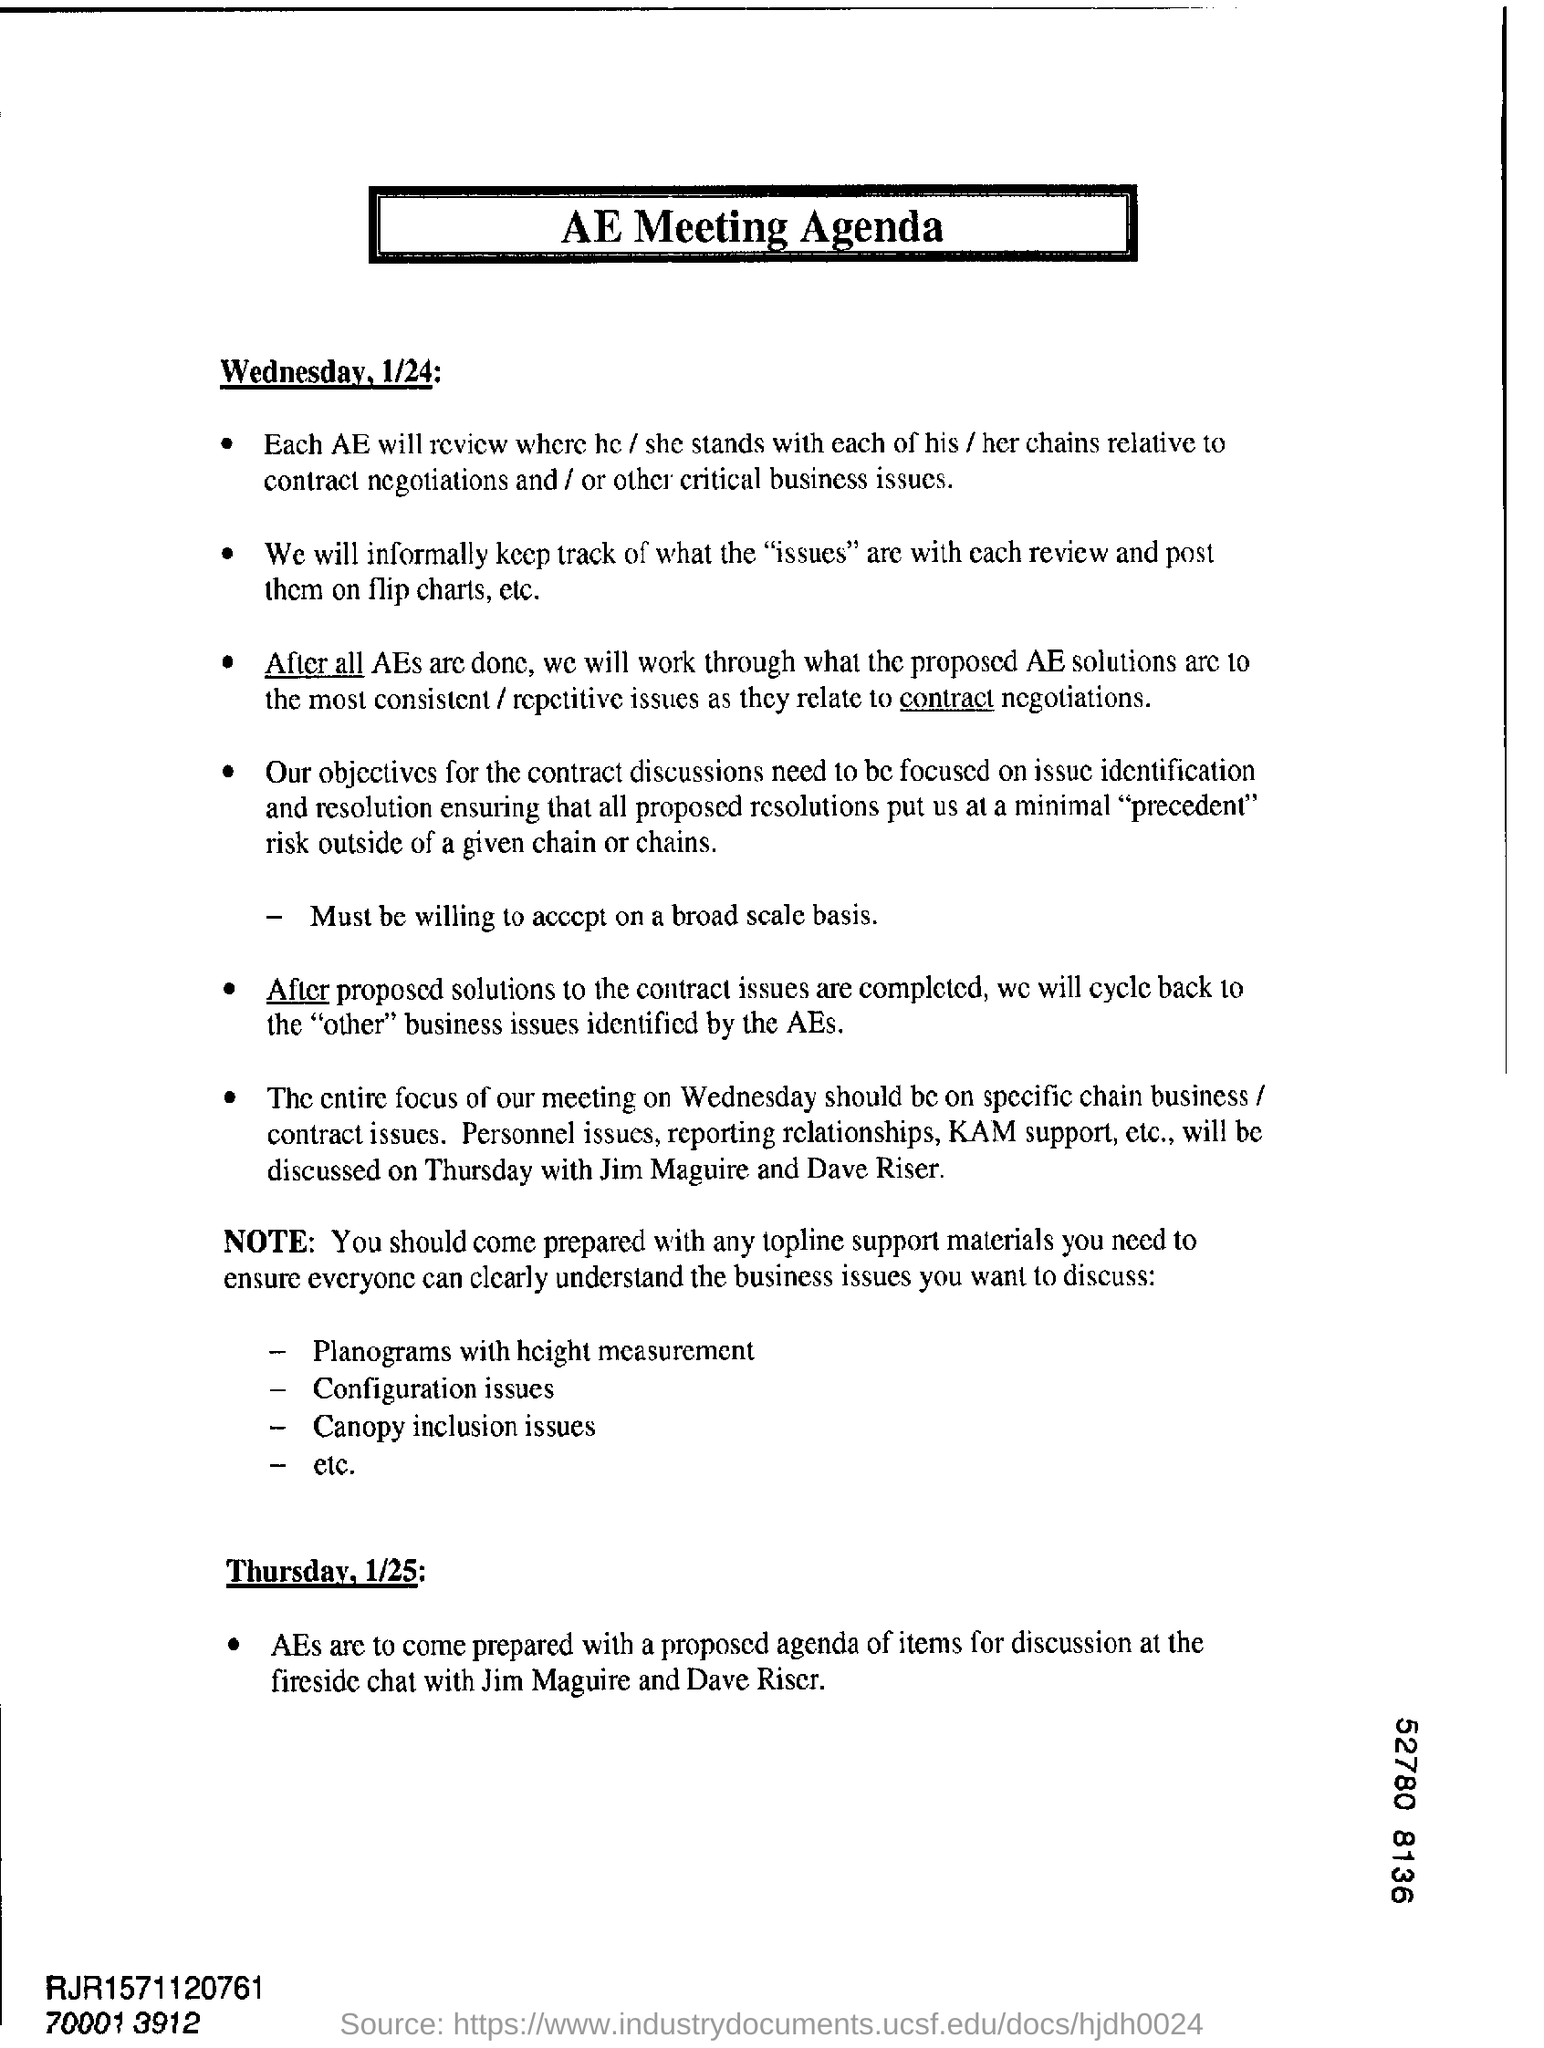The agenda mentioned in the document is related to?
Ensure brevity in your answer.  AE Meeting Agenda. 